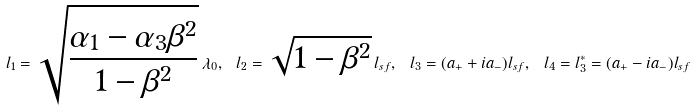Convert formula to latex. <formula><loc_0><loc_0><loc_500><loc_500>l _ { 1 } = \sqrt { \frac { \alpha _ { 1 } - \alpha _ { 3 } \beta ^ { 2 } } { 1 - \beta ^ { 2 } } } \, \lambda _ { 0 } , \ l _ { 2 } = \sqrt { 1 - \beta ^ { 2 } } \, l _ { s f } , \ l _ { 3 } = ( a _ { + } + i a _ { - } ) l _ { s f } , \ l _ { 4 } = l _ { 3 } ^ { * } = ( a _ { + } - i a _ { - } ) l _ { s f }</formula> 